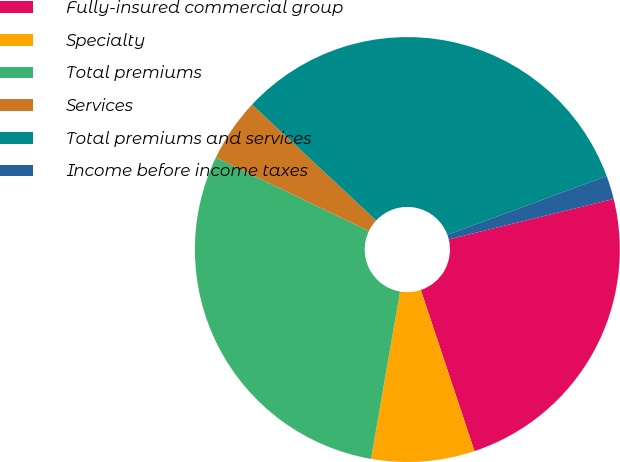Convert chart to OTSL. <chart><loc_0><loc_0><loc_500><loc_500><pie_chart><fcel>Fully-insured commercial group<fcel>Specialty<fcel>Total premiums<fcel>Services<fcel>Total premiums and services<fcel>Income before income taxes<nl><fcel>23.71%<fcel>7.85%<fcel>29.4%<fcel>4.82%<fcel>32.43%<fcel>1.79%<nl></chart> 